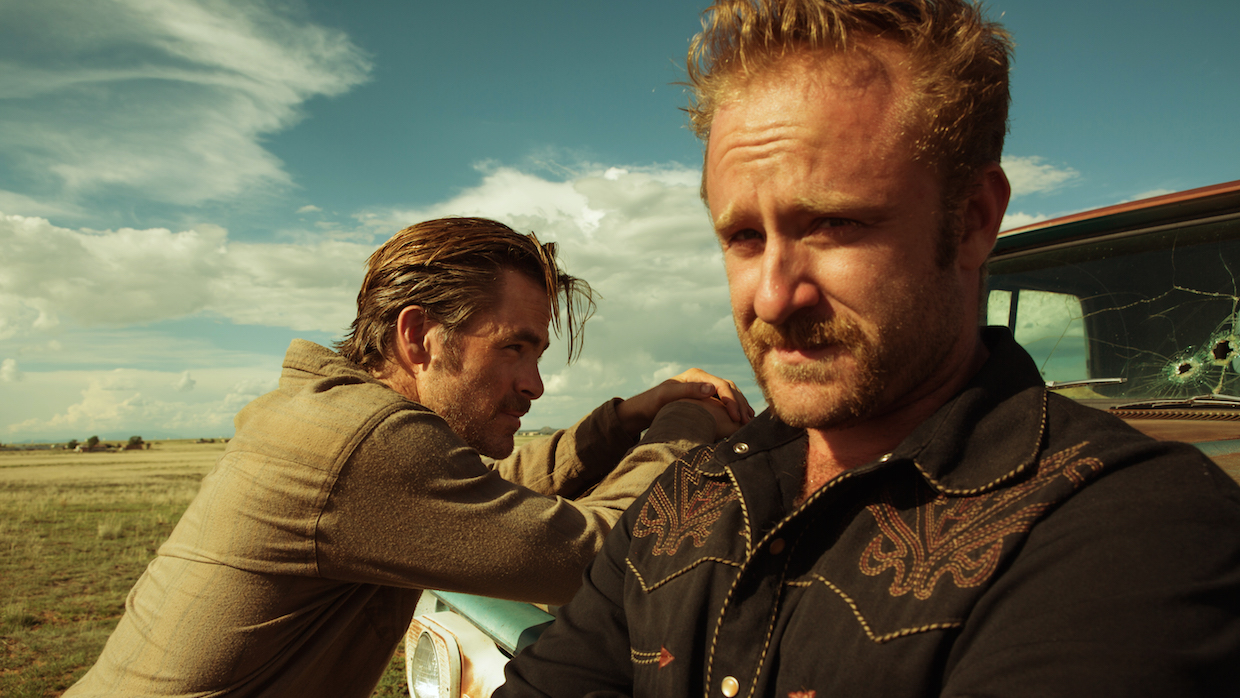Describe the relationship between the two men based on their body language. Based on their body language, the relationship between the two men appears to be one of camaraderie mixed with tension. The man in the foreground, with his intense gaze and rugged appearance, seems focused and perhaps troubled. His co-star in the background, leaning casually against the car, suggests a more relaxed or contemplative demeanor. This contrast may indicate a dynamic where one is more driven or anxious, while the other provides a steadier counterbalance. Can you speculate what happened just before and what might happen next? Just before this moment, the characters might have experienced a confrontation or escape, judging by the cracked windshield and their intense expressions. They could have been in a car chase or a shootout. The man in the foreground appears to be gathering his thoughts or planning their next move, while his companion’s casual stance suggests a momentary relief or contemplation. What might happen next could involve a continuation of their journey, possibly engaging in another tense encounter or making a critical decision about their next steps. The scene sets up an anticipation of ongoing conflict and the need for quick thinking and action. 